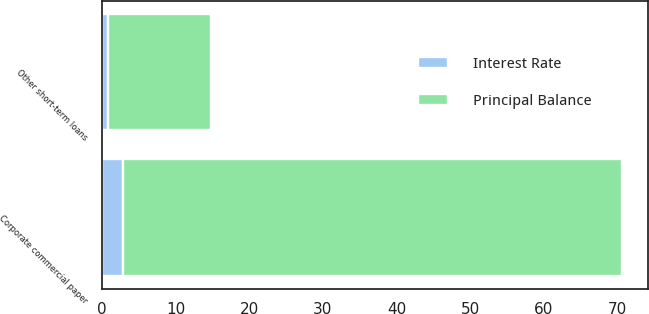Convert chart. <chart><loc_0><loc_0><loc_500><loc_500><stacked_bar_chart><ecel><fcel>Corporate commercial paper<fcel>Other short-term loans<nl><fcel>Principal Balance<fcel>67.8<fcel>14<nl><fcel>Interest Rate<fcel>2.8<fcel>0.8<nl></chart> 